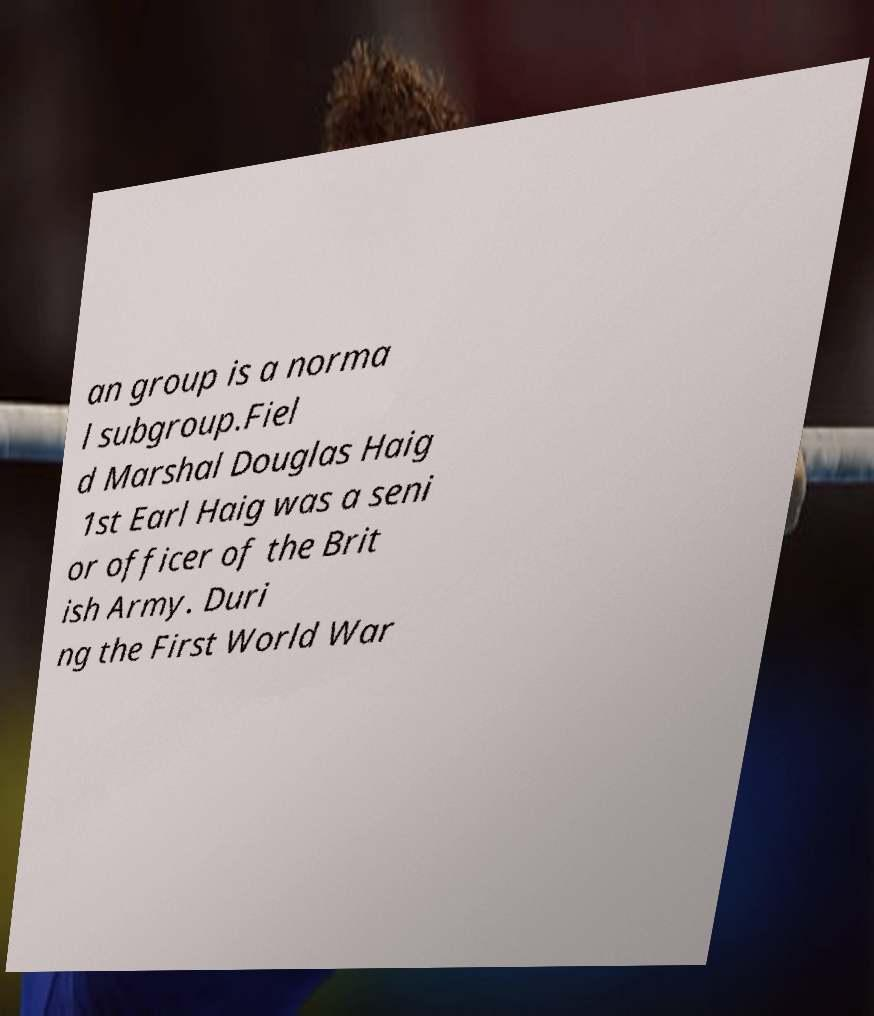Please read and relay the text visible in this image. What does it say? an group is a norma l subgroup.Fiel d Marshal Douglas Haig 1st Earl Haig was a seni or officer of the Brit ish Army. Duri ng the First World War 